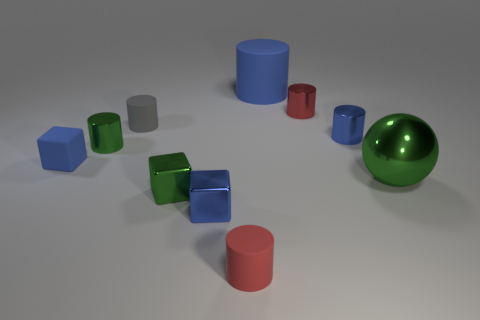Subtract all green cylinders. How many cylinders are left? 5 Subtract all green cylinders. How many cylinders are left? 5 Subtract all purple cylinders. Subtract all purple balls. How many cylinders are left? 6 Subtract all cylinders. How many objects are left? 4 Add 1 tiny shiny cylinders. How many tiny shiny cylinders exist? 4 Subtract 1 green cubes. How many objects are left? 9 Subtract all red matte things. Subtract all small blue blocks. How many objects are left? 7 Add 5 tiny metallic cubes. How many tiny metallic cubes are left? 7 